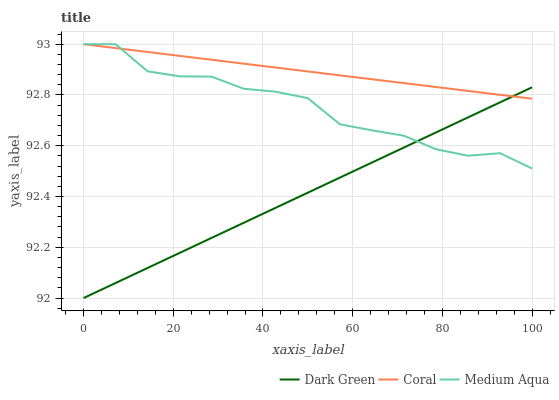Does Dark Green have the minimum area under the curve?
Answer yes or no. Yes. Does Coral have the maximum area under the curve?
Answer yes or no. Yes. Does Medium Aqua have the minimum area under the curve?
Answer yes or no. No. Does Medium Aqua have the maximum area under the curve?
Answer yes or no. No. Is Coral the smoothest?
Answer yes or no. Yes. Is Medium Aqua the roughest?
Answer yes or no. Yes. Is Dark Green the smoothest?
Answer yes or no. No. Is Dark Green the roughest?
Answer yes or no. No. Does Dark Green have the lowest value?
Answer yes or no. Yes. Does Medium Aqua have the lowest value?
Answer yes or no. No. Does Medium Aqua have the highest value?
Answer yes or no. Yes. Does Dark Green have the highest value?
Answer yes or no. No. Does Medium Aqua intersect Coral?
Answer yes or no. Yes. Is Medium Aqua less than Coral?
Answer yes or no. No. Is Medium Aqua greater than Coral?
Answer yes or no. No. 